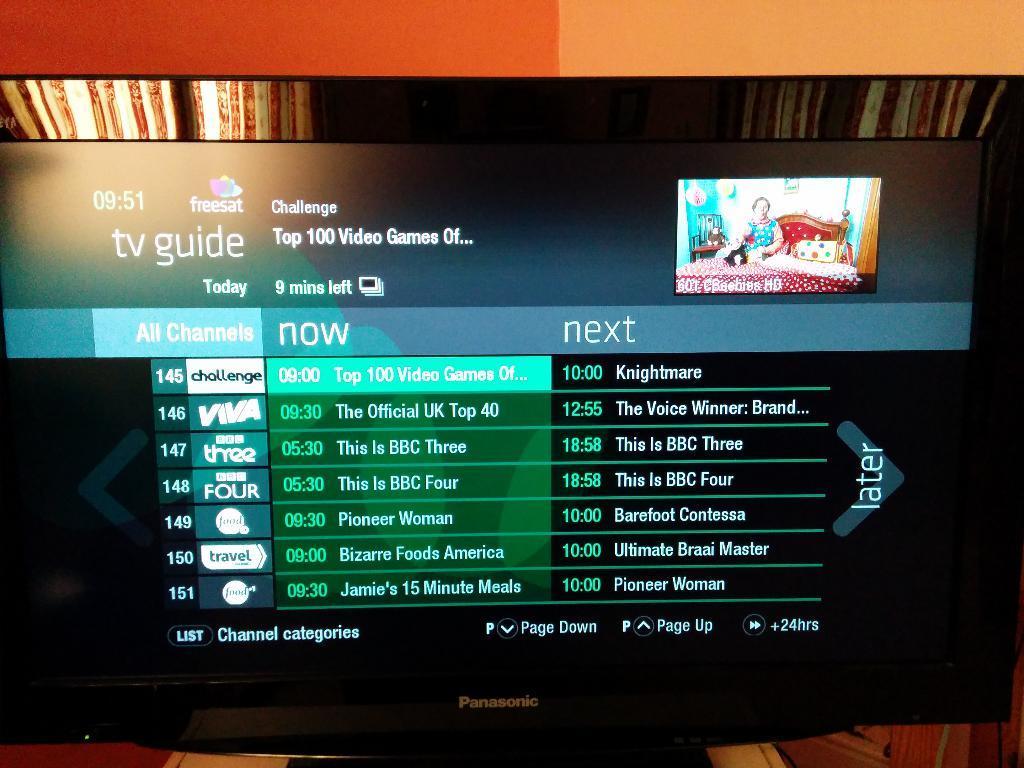Could you give a brief overview of what you see in this image? It is a t. v. there are texts on this, on the right side there is an image, in that there is a person on the bed. 